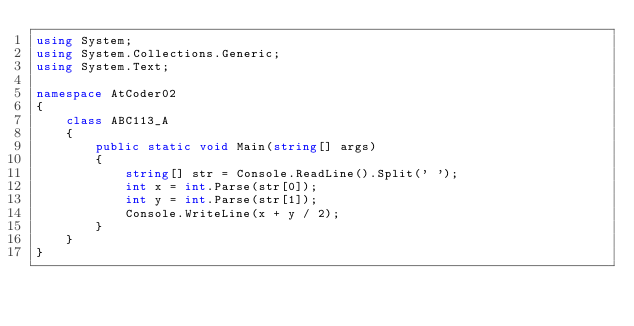<code> <loc_0><loc_0><loc_500><loc_500><_C#_>using System;
using System.Collections.Generic;
using System.Text;

namespace AtCoder02
{
    class ABC113_A
    {
        public static void Main(string[] args)
        {
            string[] str = Console.ReadLine().Split(' ');
            int x = int.Parse(str[0]);
            int y = int.Parse(str[1]);
            Console.WriteLine(x + y / 2);
        }
    }
}</code> 